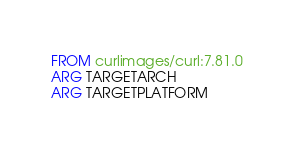Convert code to text. <code><loc_0><loc_0><loc_500><loc_500><_Dockerfile_>FROM curlimages/curl:7.81.0
ARG TARGETARCH
ARG TARGETPLATFORM

</code> 